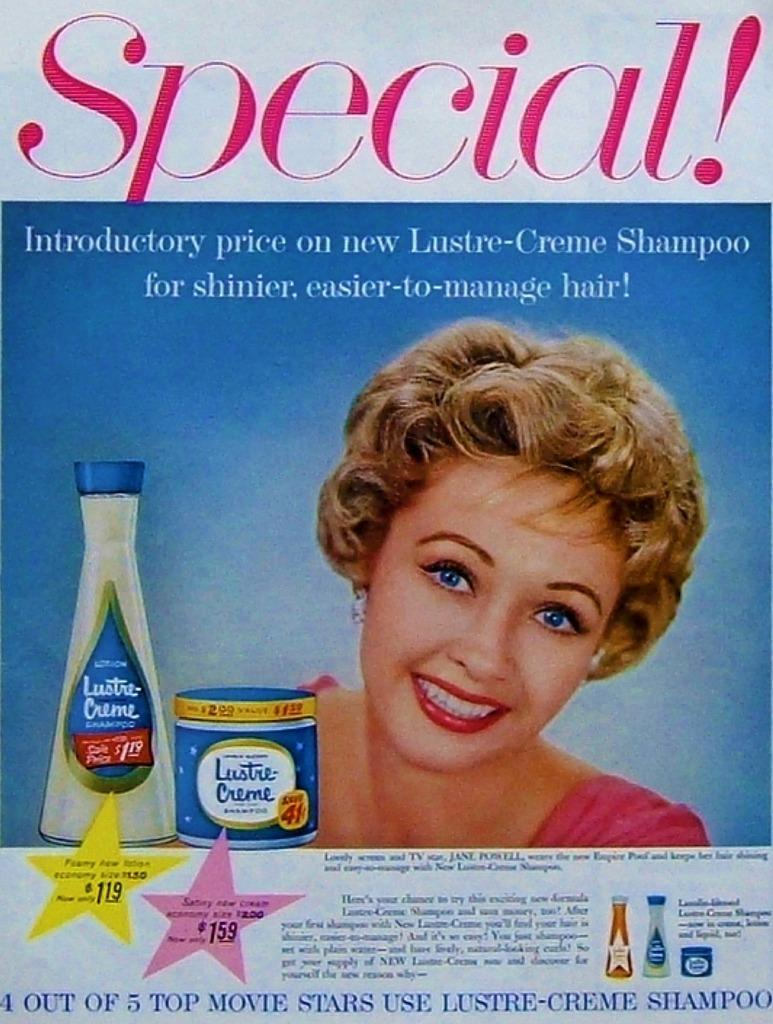<image>
Present a compact description of the photo's key features. advertisement with the text Special! Introductory price on new Lustre-Creme Shampoo for shinier, easier-to-manage hair! 